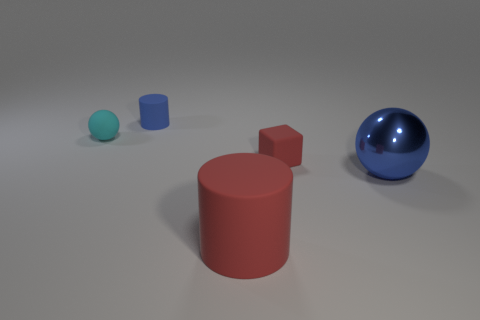What is the shape of the rubber thing that is the same color as the large ball?
Keep it short and to the point. Cylinder. How many other objects are the same size as the cyan rubber object?
Offer a very short reply. 2. The big shiny object has what color?
Provide a short and direct response. Blue. There is a small rubber sphere; does it have the same color as the cylinder in front of the small rubber cylinder?
Keep it short and to the point. No. The red thing that is the same material as the red block is what size?
Give a very brief answer. Large. Is there a block of the same color as the large ball?
Your response must be concise. No. What number of objects are spheres that are right of the rubber ball or big metal objects?
Your answer should be compact. 1. Are the big blue object and the small sphere that is behind the big rubber cylinder made of the same material?
Your answer should be compact. No. What size is the rubber cylinder that is the same color as the small rubber cube?
Provide a short and direct response. Large. Is there a cylinder that has the same material as the tiny cyan ball?
Offer a terse response. Yes. 